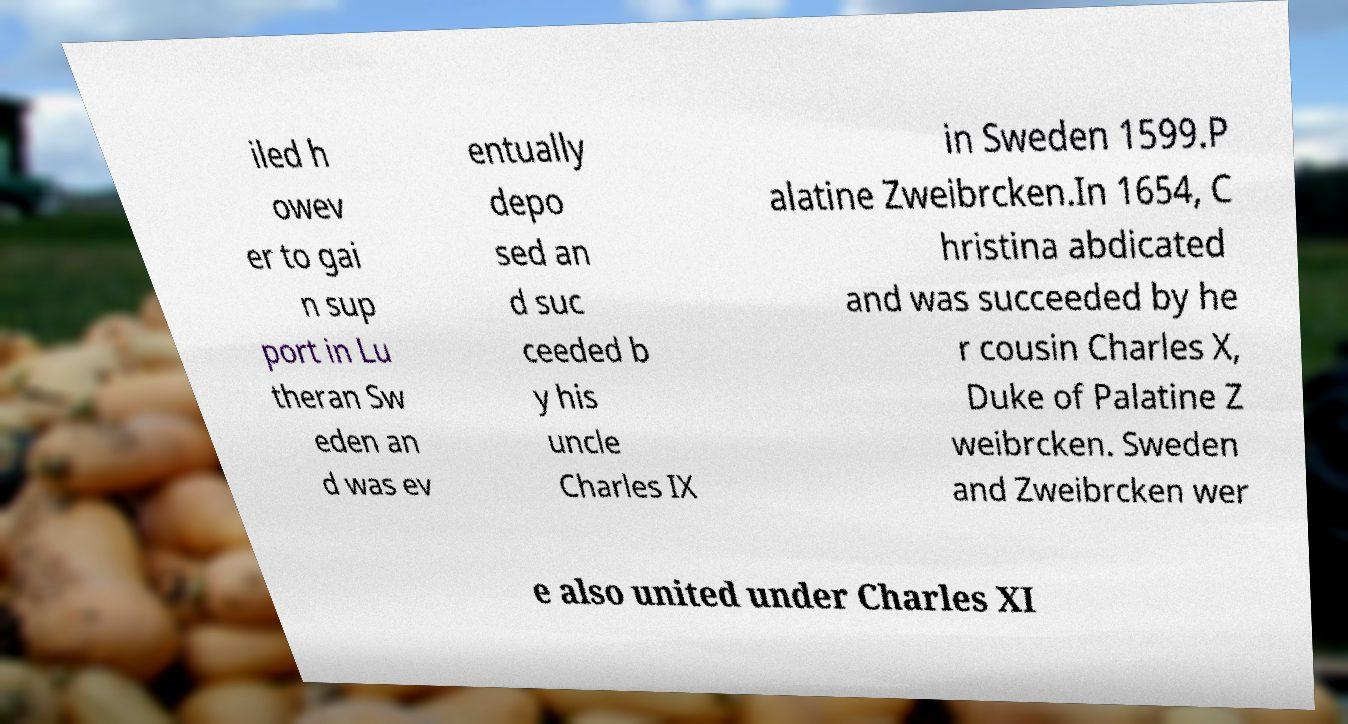Can you read and provide the text displayed in the image?This photo seems to have some interesting text. Can you extract and type it out for me? iled h owev er to gai n sup port in Lu theran Sw eden an d was ev entually depo sed an d suc ceeded b y his uncle Charles IX in Sweden 1599.P alatine Zweibrcken.In 1654, C hristina abdicated and was succeeded by he r cousin Charles X, Duke of Palatine Z weibrcken. Sweden and Zweibrcken wer e also united under Charles XI 